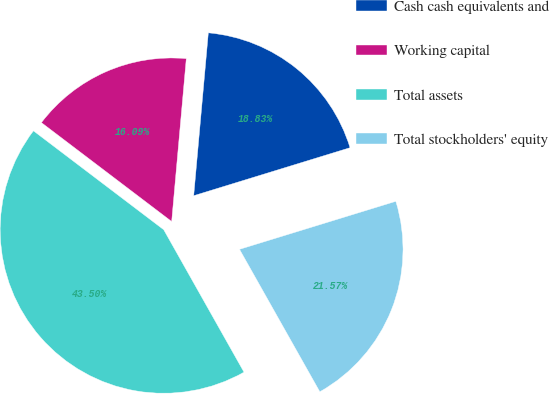Convert chart. <chart><loc_0><loc_0><loc_500><loc_500><pie_chart><fcel>Cash cash equivalents and<fcel>Working capital<fcel>Total assets<fcel>Total stockholders' equity<nl><fcel>18.83%<fcel>16.09%<fcel>43.5%<fcel>21.57%<nl></chart> 